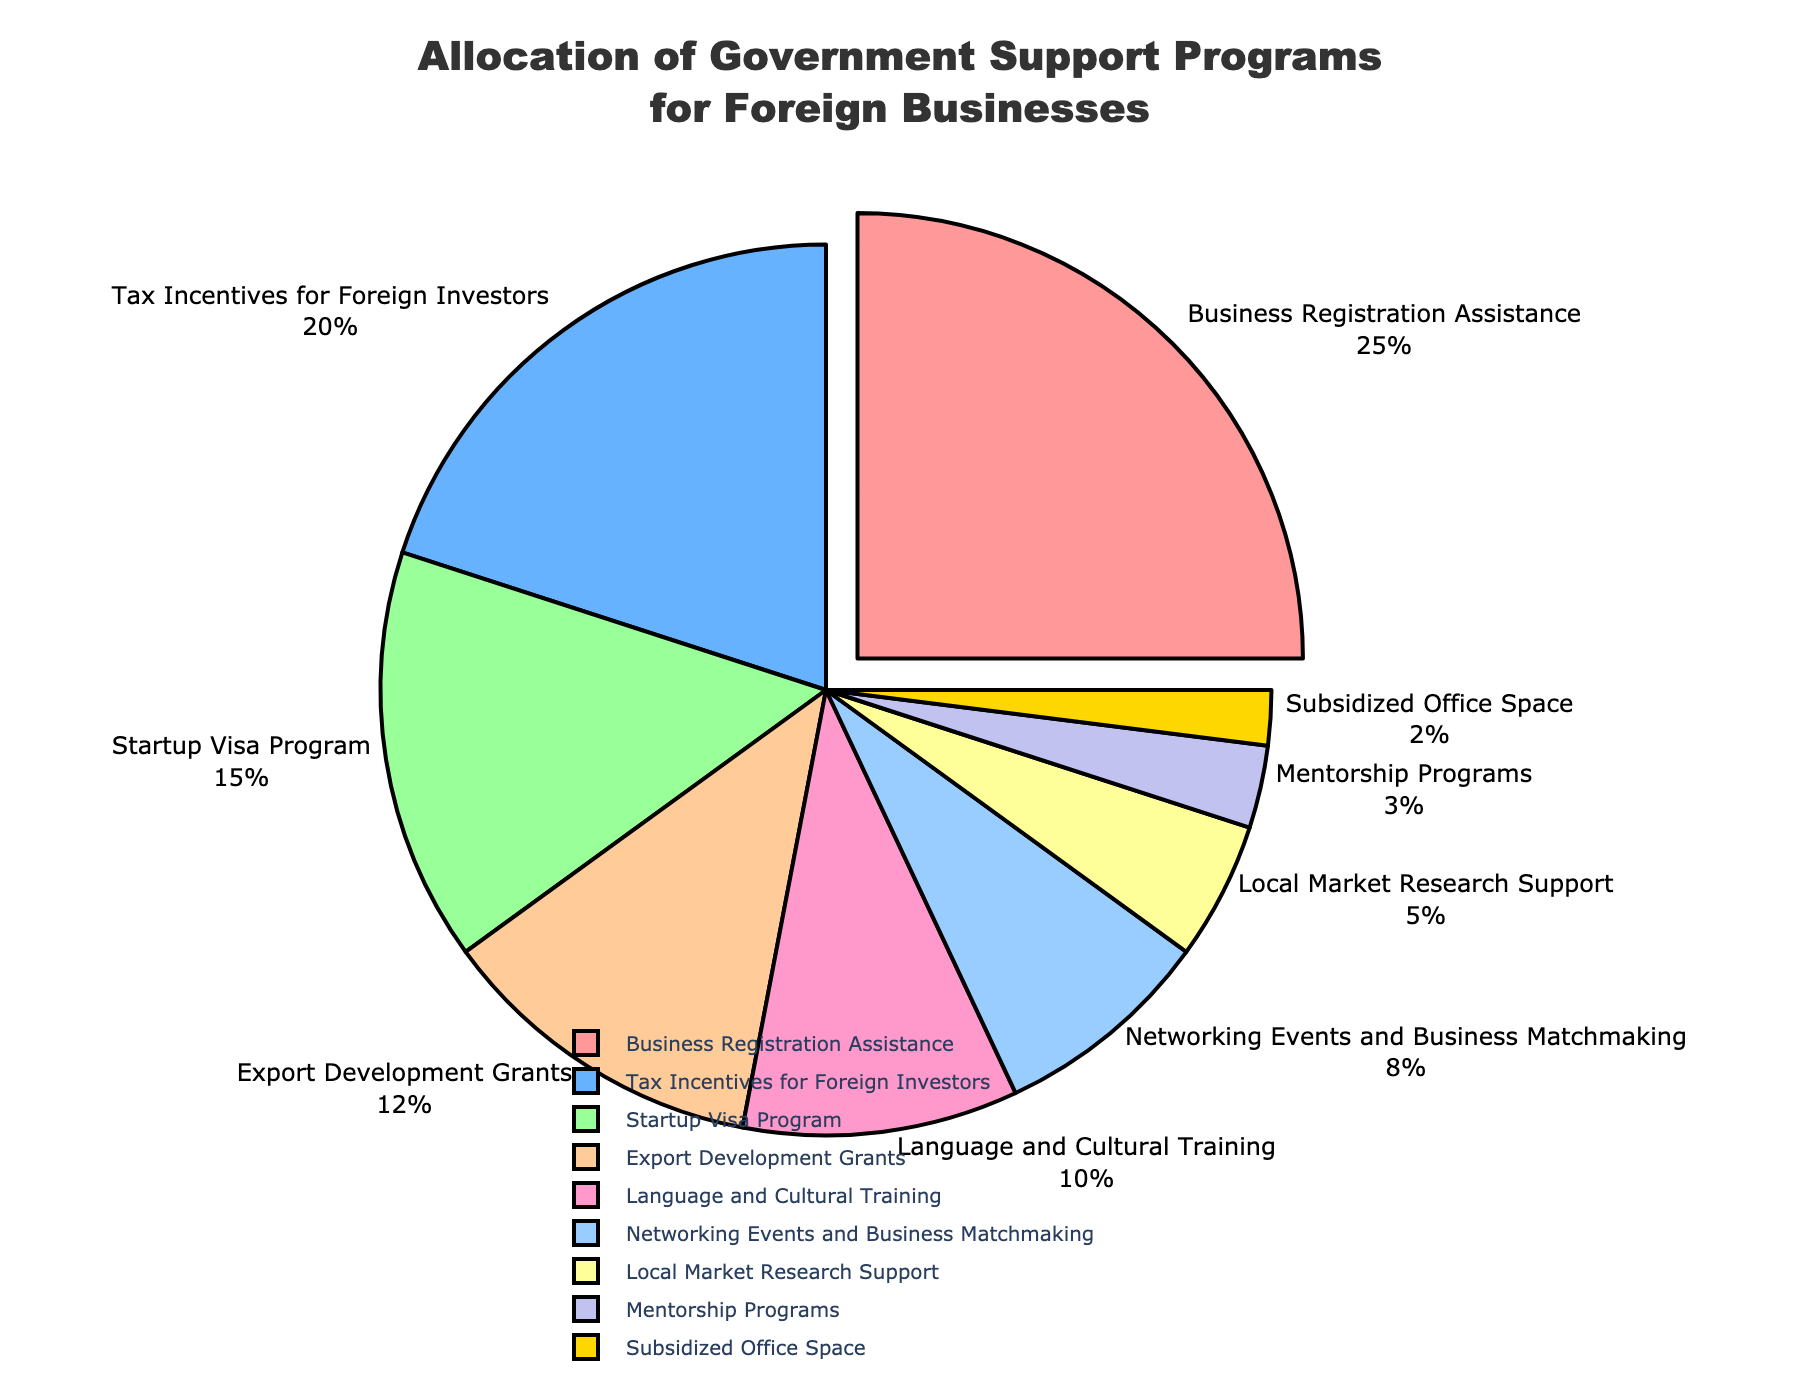What is the most allocated government support program for foreign businesses? The segment pulled out from the pie chart represents the most allocated program. By observing the chart, we can see that "Business Registration Assistance" has the largest section.
Answer: Business Registration Assistance Which government support program receives the least percentage allocation? In the pie chart, the smallest segment corresponds to the "Subsidized Office Space," which is positioned at the bottom of the chart.
Answer: Subsidized Office Space How much more percentage allocation does the "Startup Visa Program" have compared to "Local Market Research Support"? By checking the percentages in the pie chart, "Startup Visa Program" has 15% and "Local Market Research Support" has 5%. The difference is calculated as 15% - 5%.
Answer: 10% Which two programs together make up 35% of the allocation? Referring to the pie chart segments, "Tax Incentives for Foreign Investors" is 20% and "Startup Visa Program" is 15%. Summing these percentages gives 20% + 15%.
Answer: Tax Incentives for Foreign Investors and Startup Visa Program What percentage of allocation is dedicated to programs supporting interaction and mentorship? Adding "Networking Events and Business Matchmaking" (8%) and "Mentorship Programs" (3%) yields 8% + 3%.
Answer: 11% Which program has a larger allocation, "Export Development Grants" or "Language and Cultural Training"? Observing the pie chart, "Export Development Grants" is 12% and "Language and Cultural Training" is 10%. The former has a larger allocation.
Answer: Export Development Grants What is the combined percentage allocation for the three least funded programs? Adding "Subsidized Office Space" (2%), "Mentorship Programs" (3%), and "Local Market Research Support" (5%) results in 2% + 3% + 5%.
Answer: 10% Which program segment is colored yellow in the pie chart? The yellow segment represents the "Subsidized Office Space" allocation, the smallest portion of the pie chart.
Answer: Subsidized Office Space 